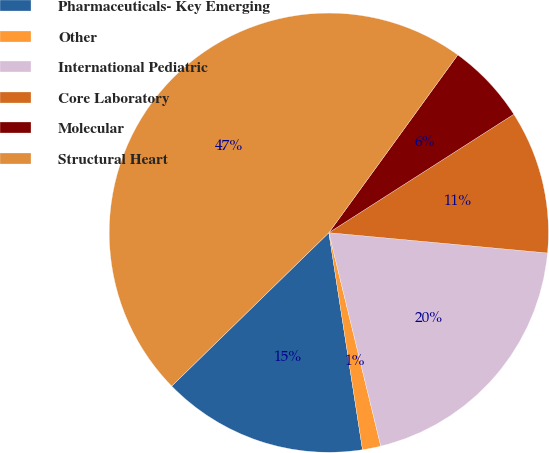Convert chart to OTSL. <chart><loc_0><loc_0><loc_500><loc_500><pie_chart><fcel>Pharmaceuticals- Key Emerging<fcel>Other<fcel>International Pediatric<fcel>Core Laboratory<fcel>Molecular<fcel>Structural Heart<nl><fcel>15.14%<fcel>1.35%<fcel>19.73%<fcel>10.54%<fcel>5.95%<fcel>47.3%<nl></chart> 